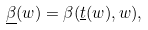Convert formula to latex. <formula><loc_0><loc_0><loc_500><loc_500>\underline { \beta } ( w ) = \beta ( \underline { t } ( w ) , w ) ,</formula> 